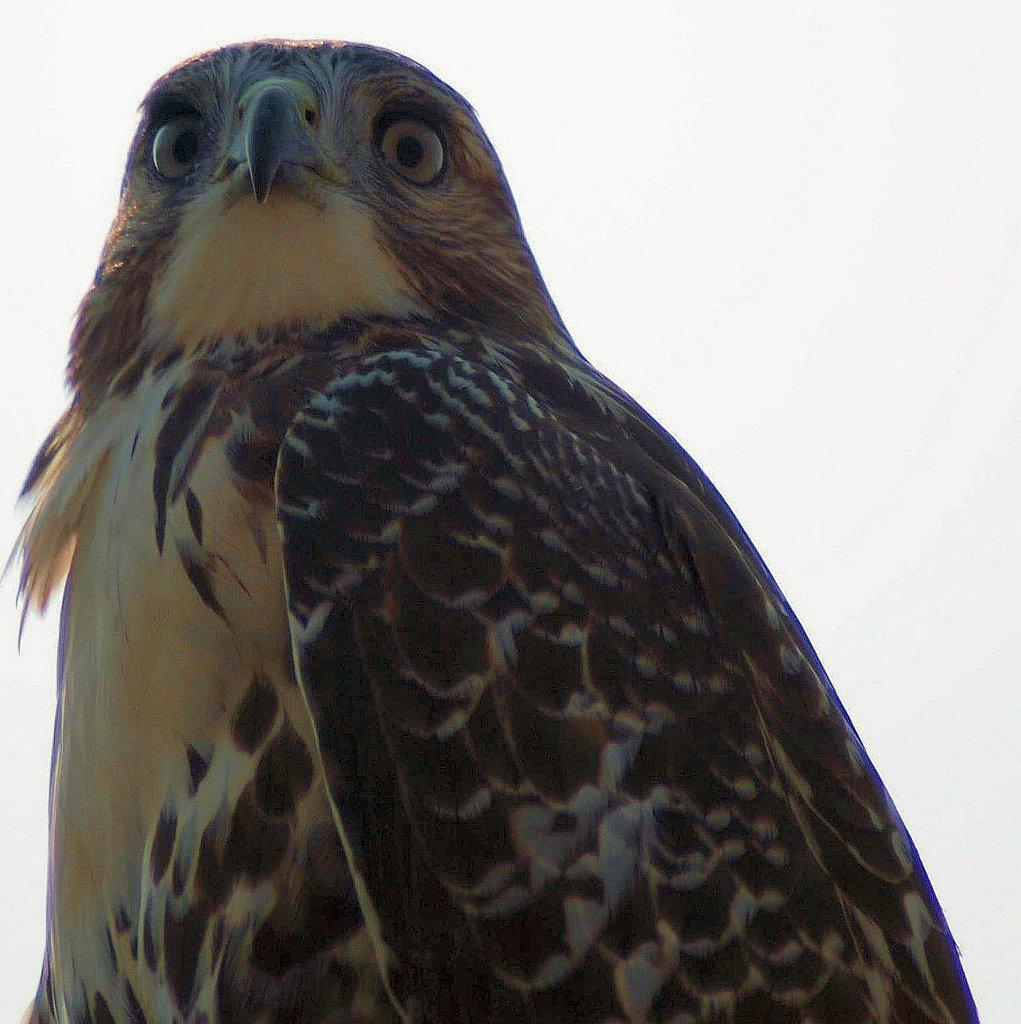In one or two sentences, can you explain what this image depicts? In this image we can see an eagle and a white background. 